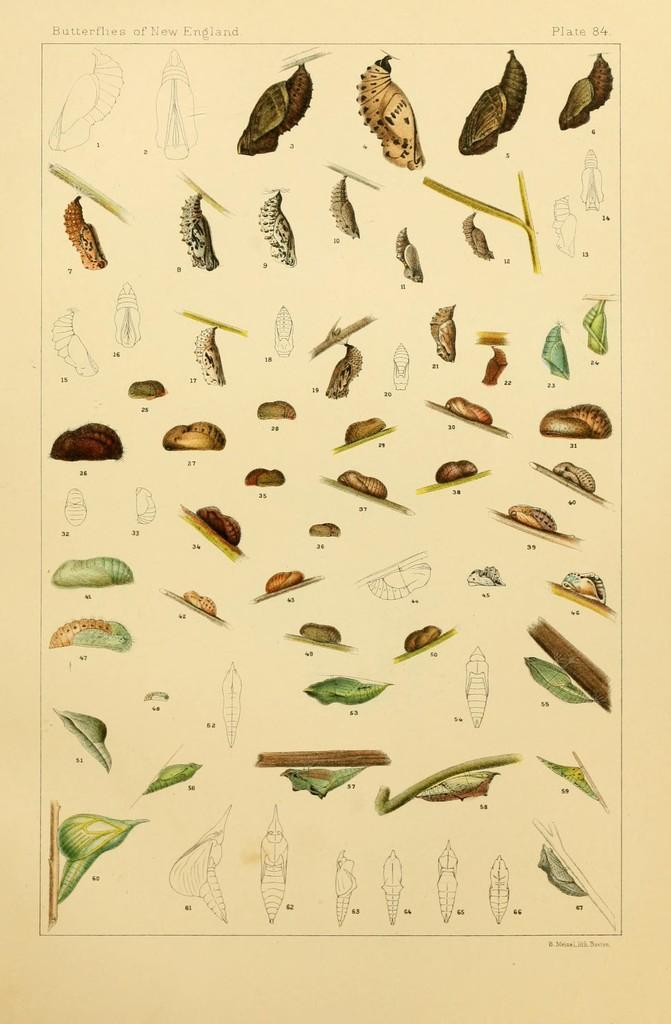What is the main subject of the image? The main subject of the image is a butterfly. Where is the butterfly located in the image? The butterfly is on a page. Is there a gun visible in the image? No, there is no gun present in the image. Can you see the butterfly taking a bath in the image? No, there is no indication of the butterfly taking a bath in the image. 